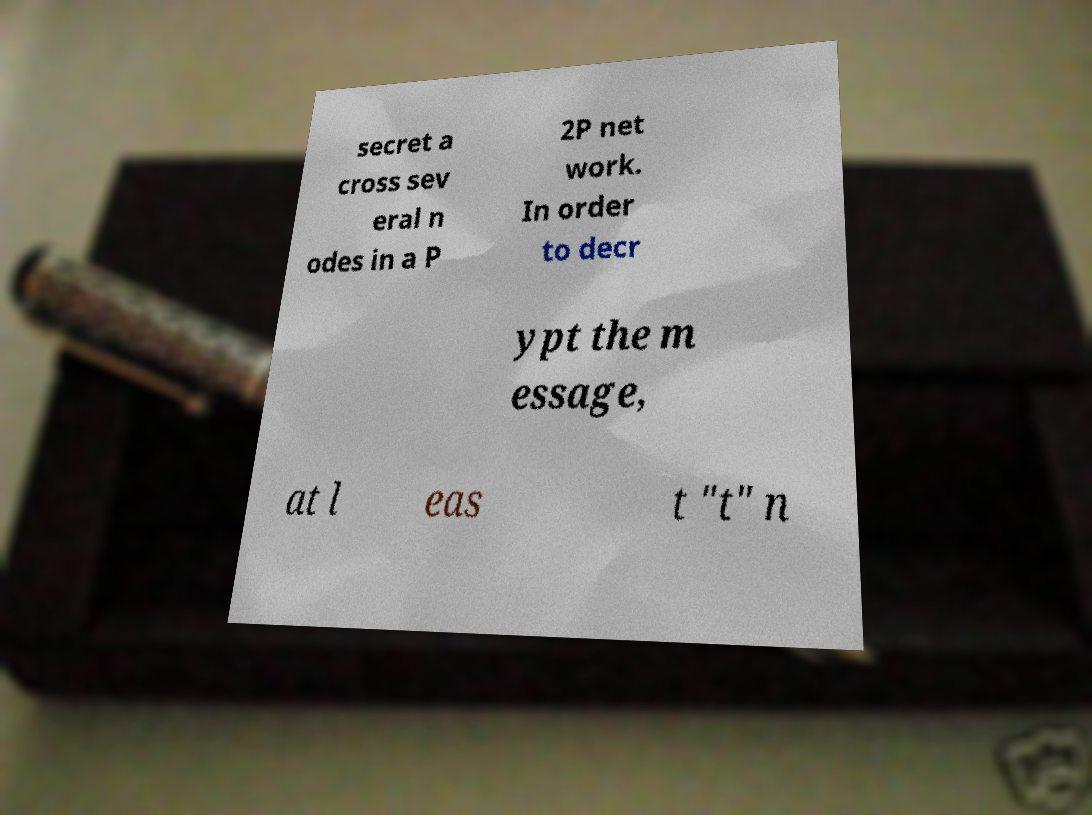I need the written content from this picture converted into text. Can you do that? secret a cross sev eral n odes in a P 2P net work. In order to decr ypt the m essage, at l eas t "t" n 